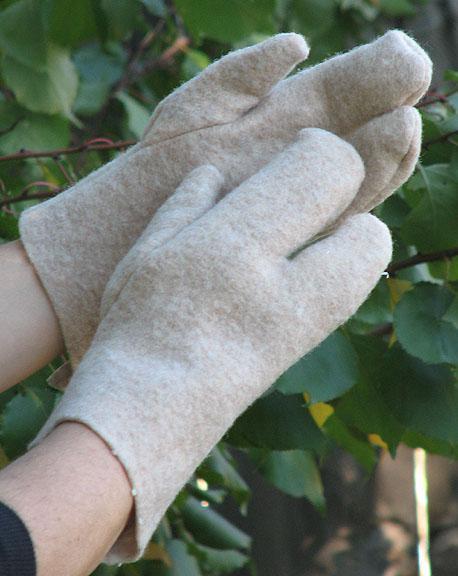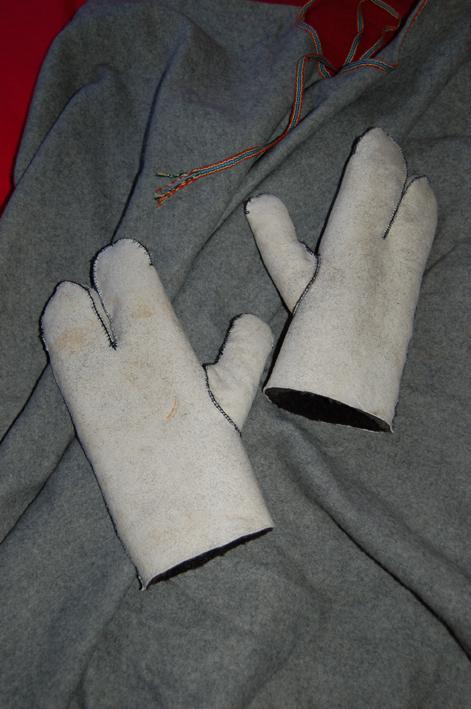The first image is the image on the left, the second image is the image on the right. Examine the images to the left and right. Is the description "only ONE of the sets of gloves is green." accurate? Answer yes or no. No. 